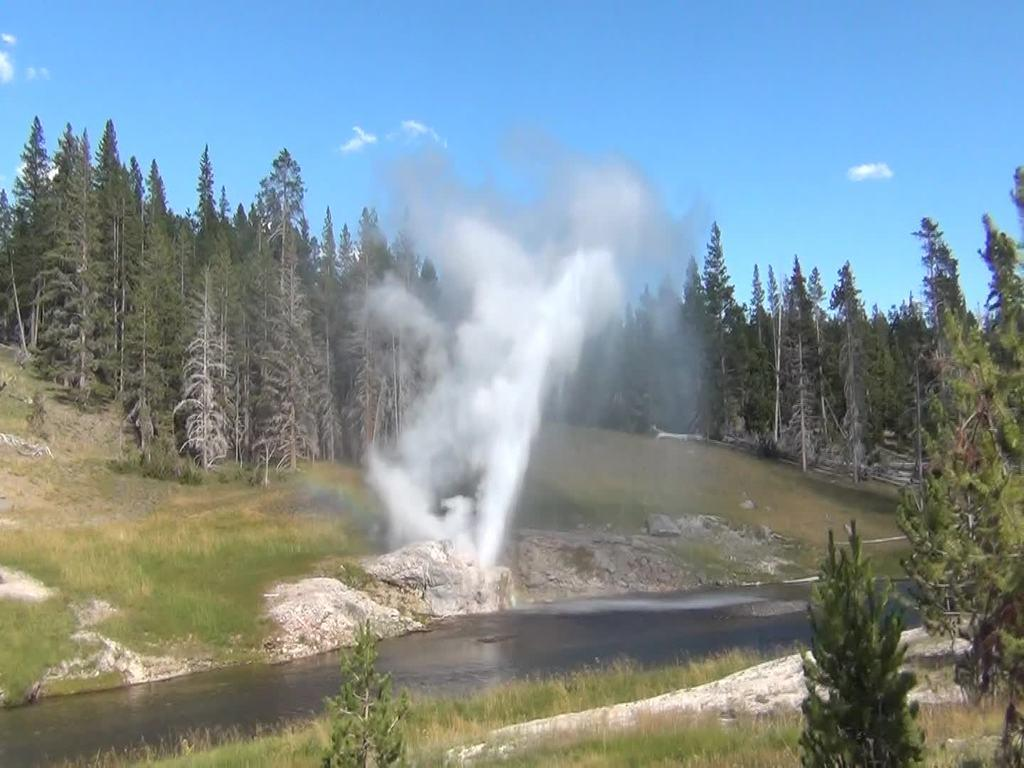What is one of the natural elements present in the image? There is water in the image. What type of vegetation can be seen in the image? There is grass and trees in the image. What other objects are present in the image? There are rocks in the image. What is the color of the smoke in the air? The smoke in the air is white-colored. What can be seen in the background of the image? There are trees and the sky in the background of the image. What type of silk fabric is draped over the trees in the image? There is no silk fabric present in the image; it features trees, grass, water, rocks, and white-colored smoke. What type of cloud can be seen in the image? The image does not show any clouds; it only features the sky in the background. 